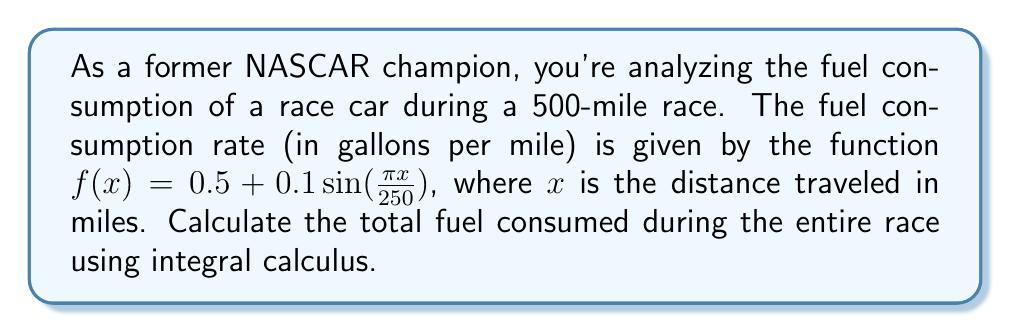Teach me how to tackle this problem. To solve this problem, we need to integrate the fuel consumption rate function over the entire distance of the race. Here's how we can approach it step-by-step:

1) The total fuel consumed is the integral of the fuel consumption rate over the distance:

   $$\text{Total Fuel} = \int_0^{500} f(x) dx$$

2) Substituting the given function:

   $$\int_0^{500} (0.5 + 0.1\sin(\frac{\pi x}{250})) dx$$

3) We can split this into two integrals:

   $$\int_0^{500} 0.5 dx + \int_0^{500} 0.1\sin(\frac{\pi x}{250}) dx$$

4) The first integral is straightforward:

   $$0.5x \big|_0^{500} = 0.5(500) - 0.5(0) = 250$$

5) For the second integral, we need to use substitution. Let $u = \frac{\pi x}{250}$, then $du = \frac{\pi}{250}dx$ or $dx = \frac{250}{\pi}du$:

   $$0.1 \cdot \frac{250}{\pi} \int_0^{2\pi} \sin(u) du$$

6) We know that $\int \sin(u) du = -\cos(u) + C$, so:

   $$0.1 \cdot \frac{250}{\pi} [-\cos(u)]_0^{2\pi} = 0.1 \cdot \frac{250}{\pi} [-\cos(2\pi) + \cos(0)] = 0$$

7) Adding the results from steps 4 and 6:

   $$250 + 0 = 250$$

Therefore, the total fuel consumed during the 500-mile race is 250 gallons.
Answer: 250 gallons 